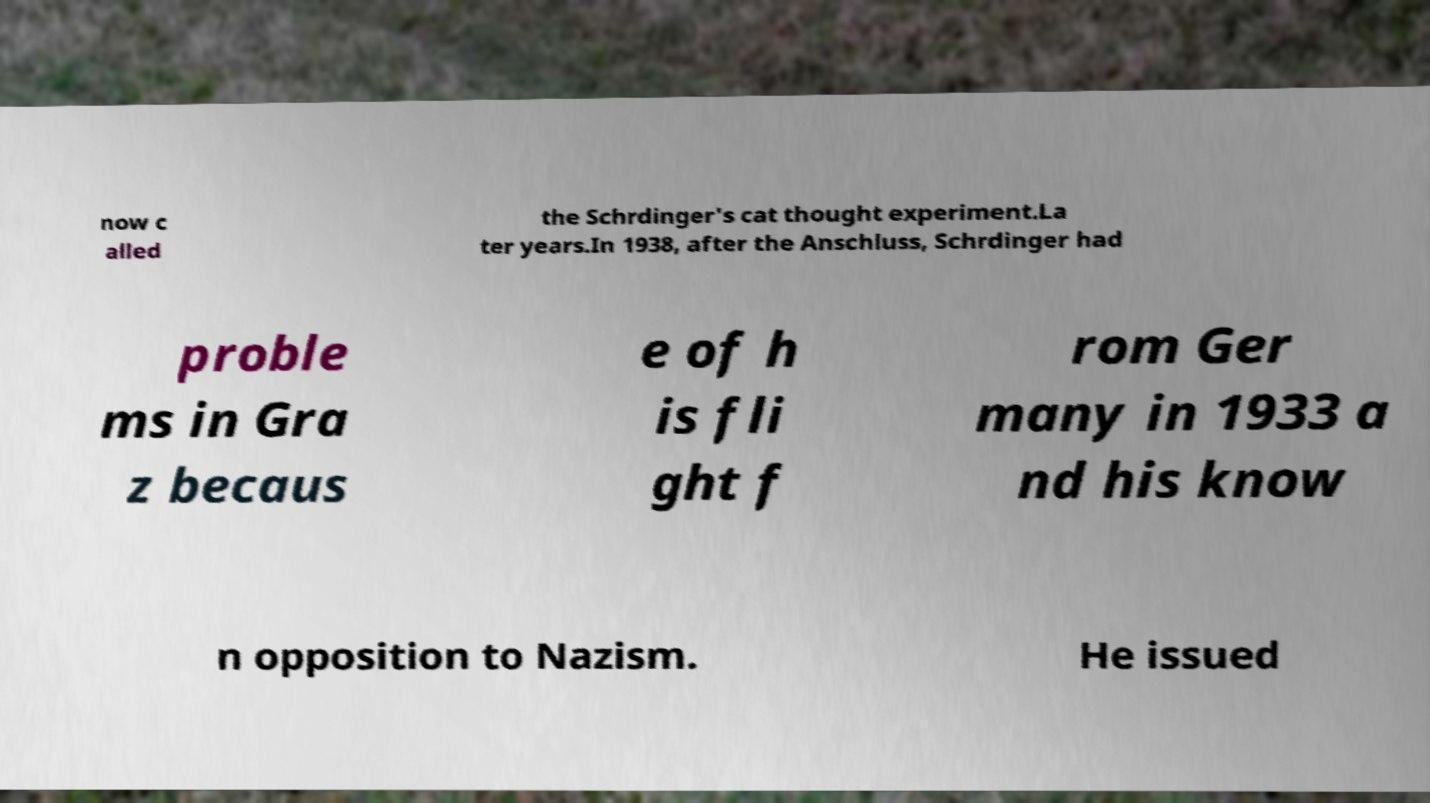For documentation purposes, I need the text within this image transcribed. Could you provide that? now c alled the Schrdinger's cat thought experiment.La ter years.In 1938, after the Anschluss, Schrdinger had proble ms in Gra z becaus e of h is fli ght f rom Ger many in 1933 a nd his know n opposition to Nazism. He issued 